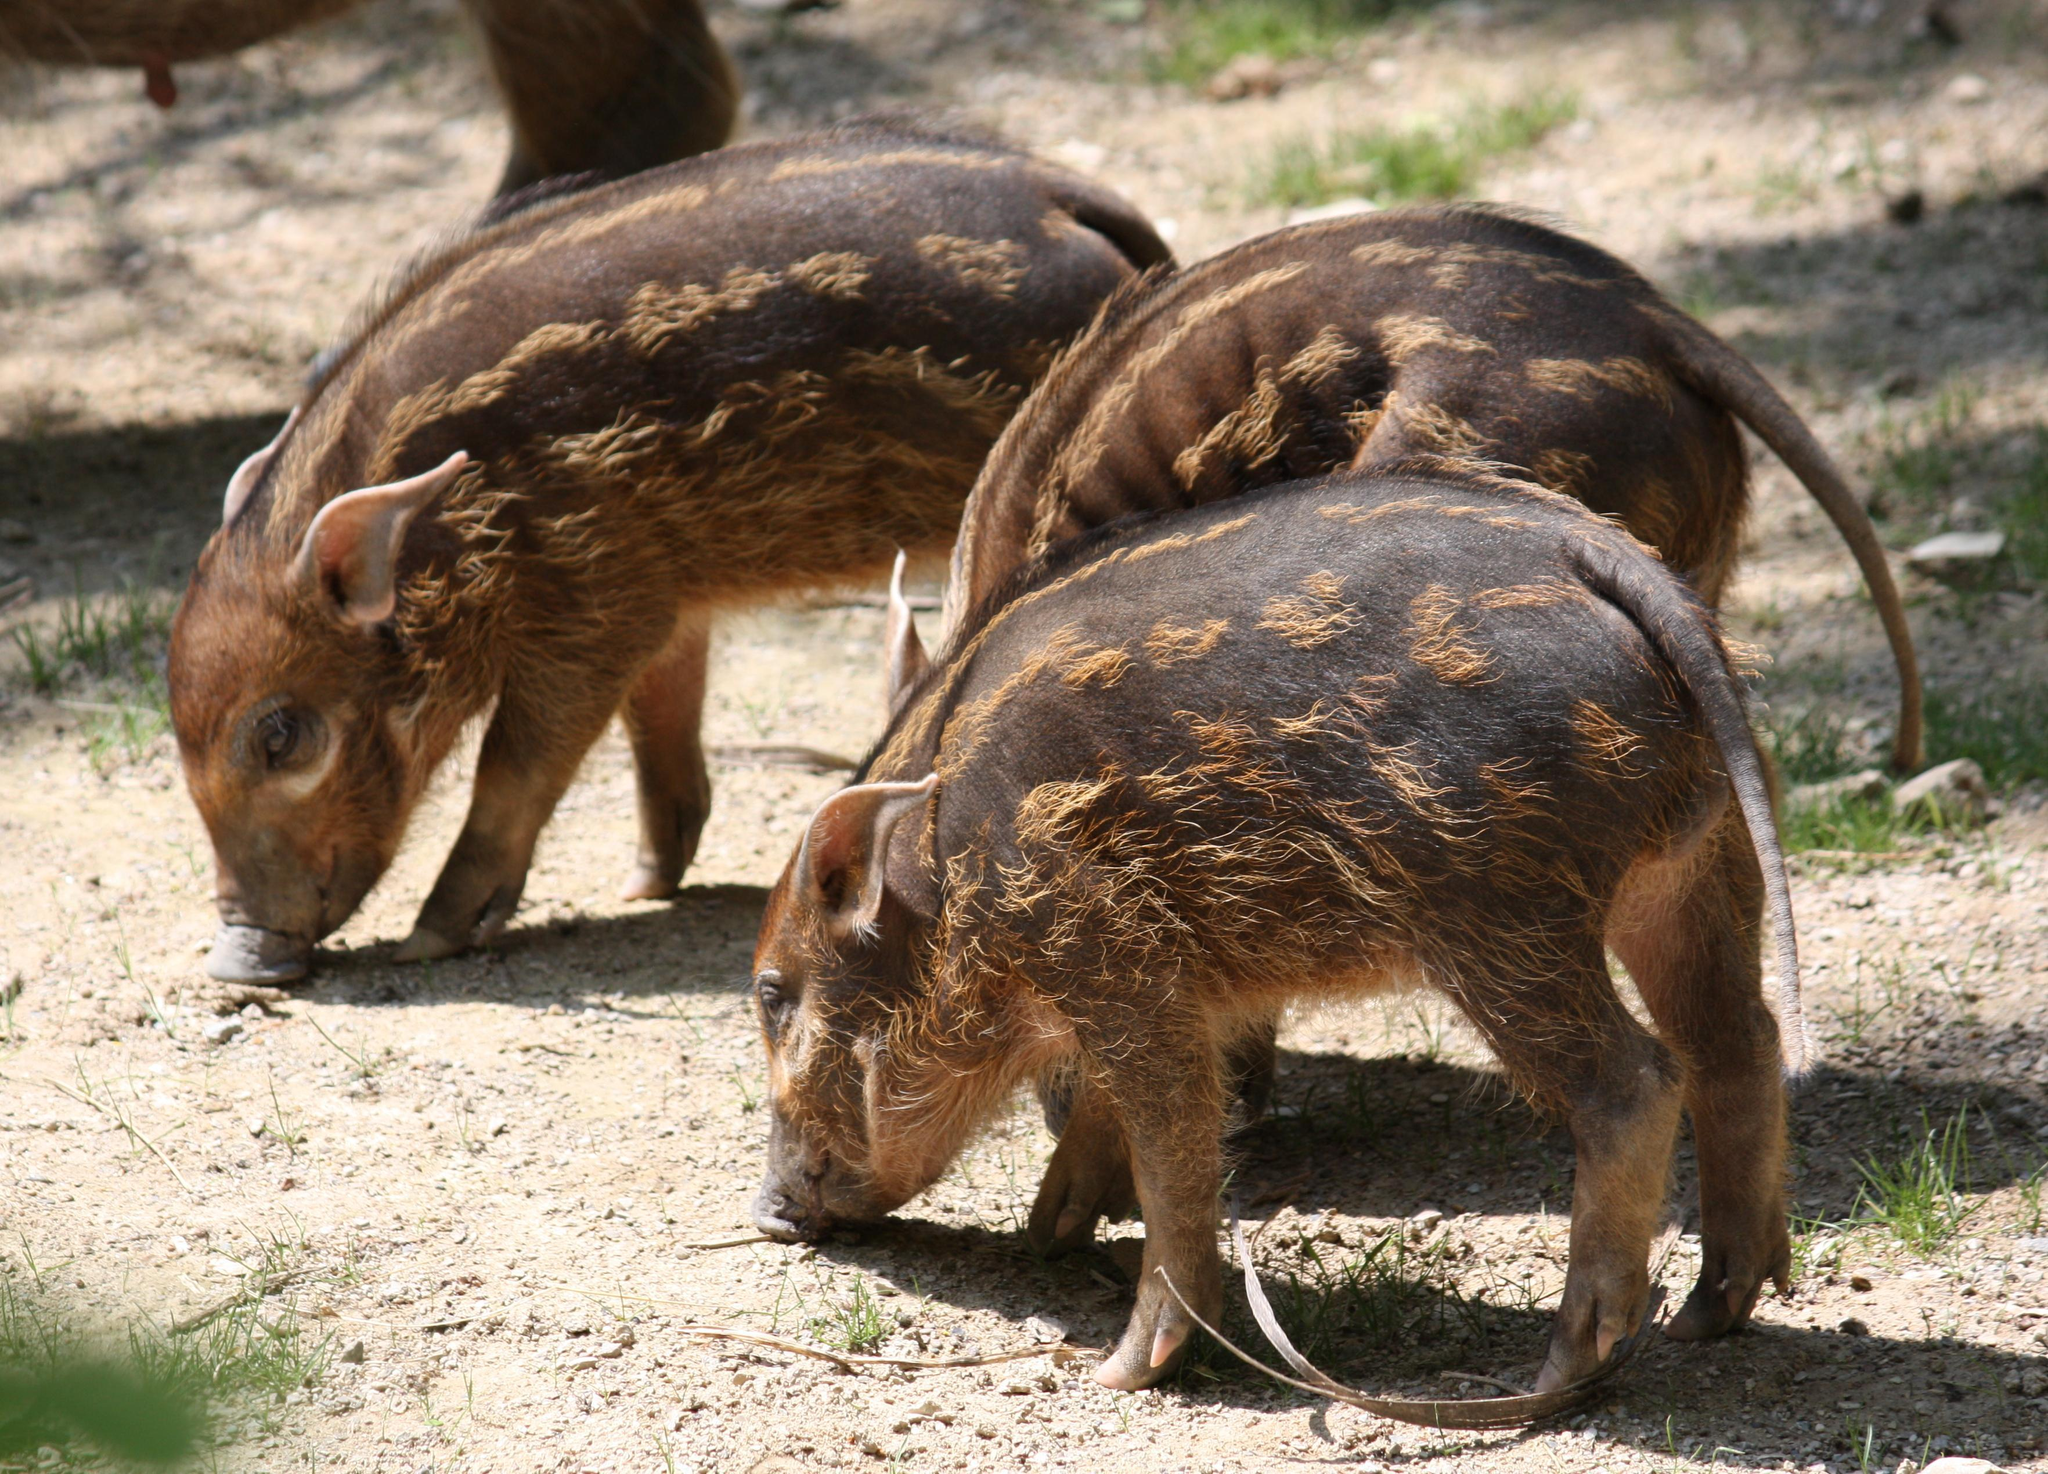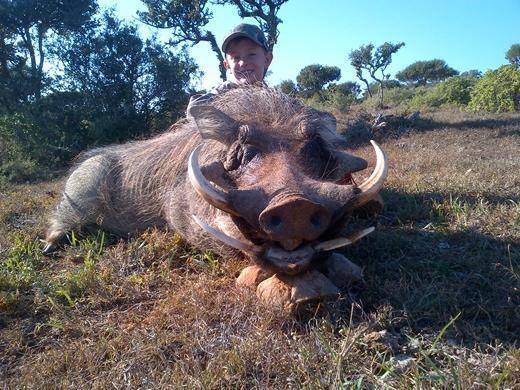The first image is the image on the left, the second image is the image on the right. For the images shown, is this caption "A hunter is posing near the wild pig in the image on the right." true? Answer yes or no. Yes. The first image is the image on the left, the second image is the image on the right. For the images displayed, is the sentence "An image shows exactly one person posed behind a killed warthog." factually correct? Answer yes or no. Yes. 